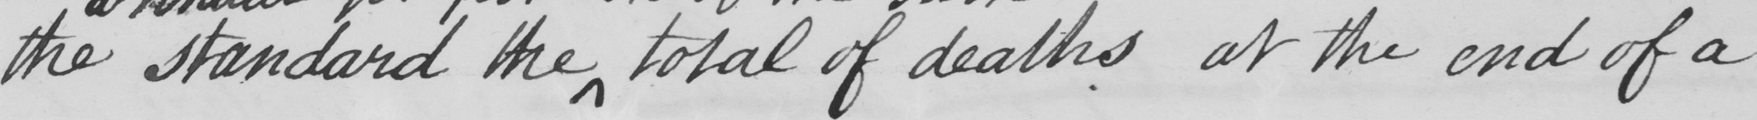Can you read and transcribe this handwriting? the standard the total of deaths at the end of a 